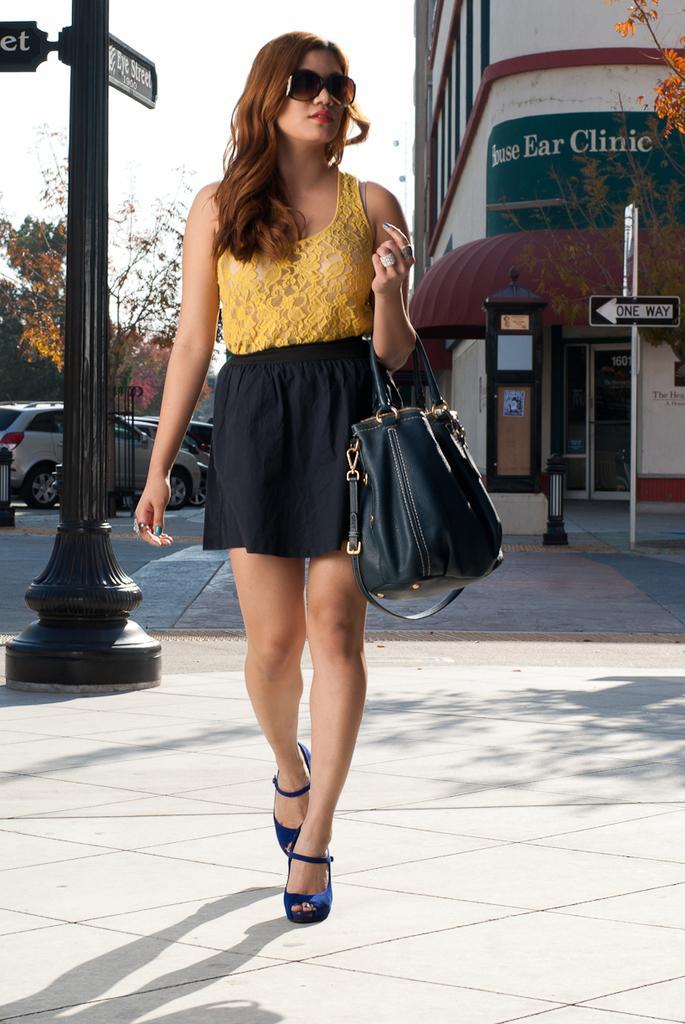Describe this image in one or two sentences. There is a woman standing in the center and she is holding a bag in her hand. In the background we can see a building which is on the right side and a few cars on the left side. 